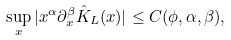<formula> <loc_0><loc_0><loc_500><loc_500>\sup _ { x } | x ^ { \alpha } \partial _ { x } ^ { \beta } \hat { K } _ { L } ( x ) | \leq C ( \phi , \alpha , \beta ) ,</formula> 